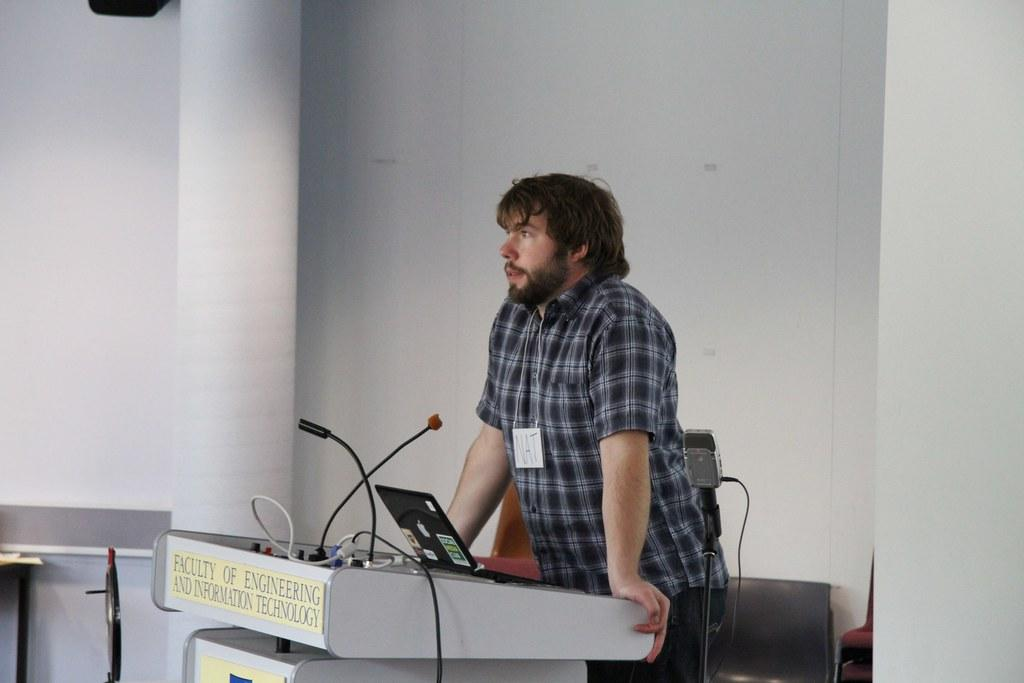What is the man in the image doing? The man is standing near the podium. What is on the podium? There are microphones and a laptop on the podium. What type of furniture is present in the image? There are chairs in the image. What can be seen in the background of the image? There is a wall in the background of the image. What decision was made by the slave in the image? There is no slave present in the image, and therefore no decision can be attributed to a slave. 